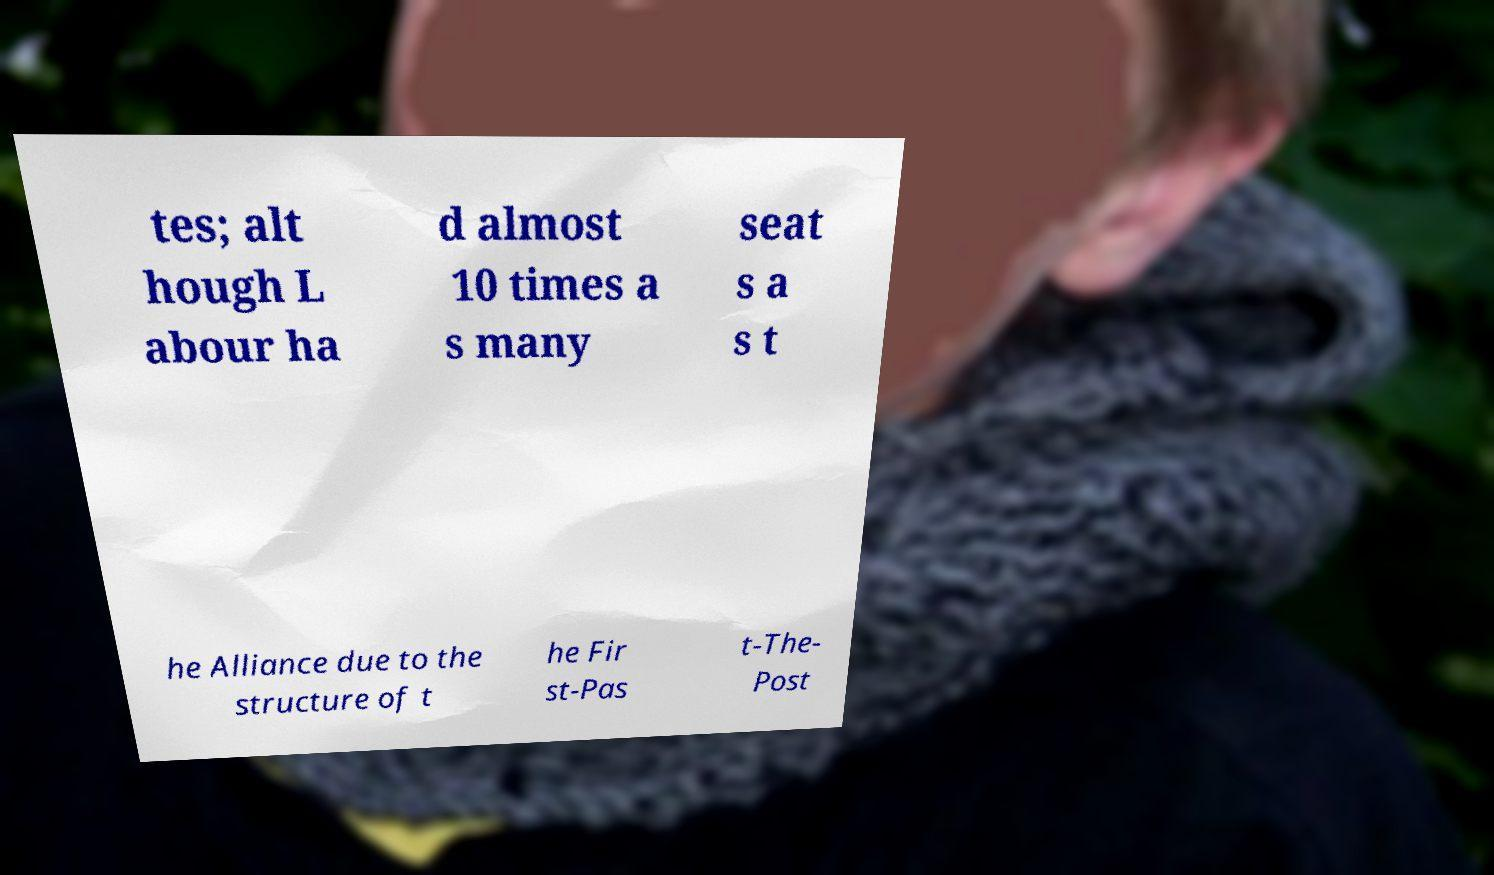Please identify and transcribe the text found in this image. tes; alt hough L abour ha d almost 10 times a s many seat s a s t he Alliance due to the structure of t he Fir st-Pas t-The- Post 